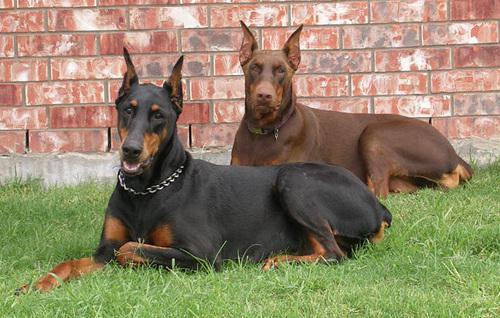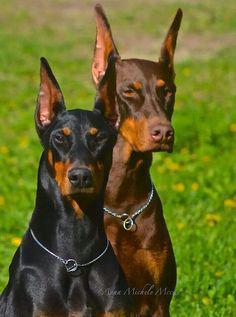The first image is the image on the left, the second image is the image on the right. Given the left and right images, does the statement "There are exactly four dogs in total." hold true? Answer yes or no. Yes. 